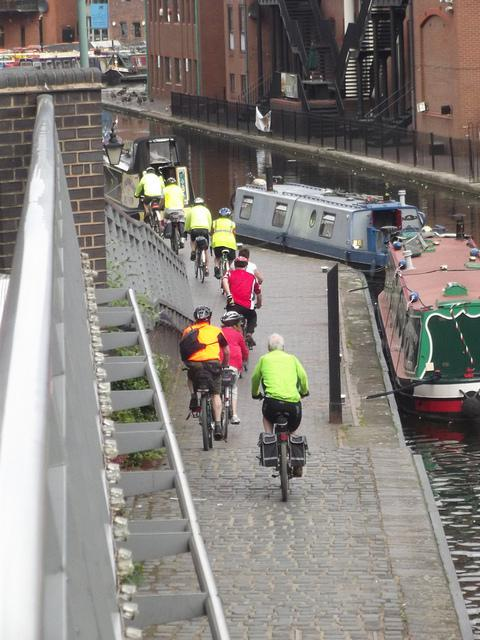Why are some cyclists wearing yellow? visibility 